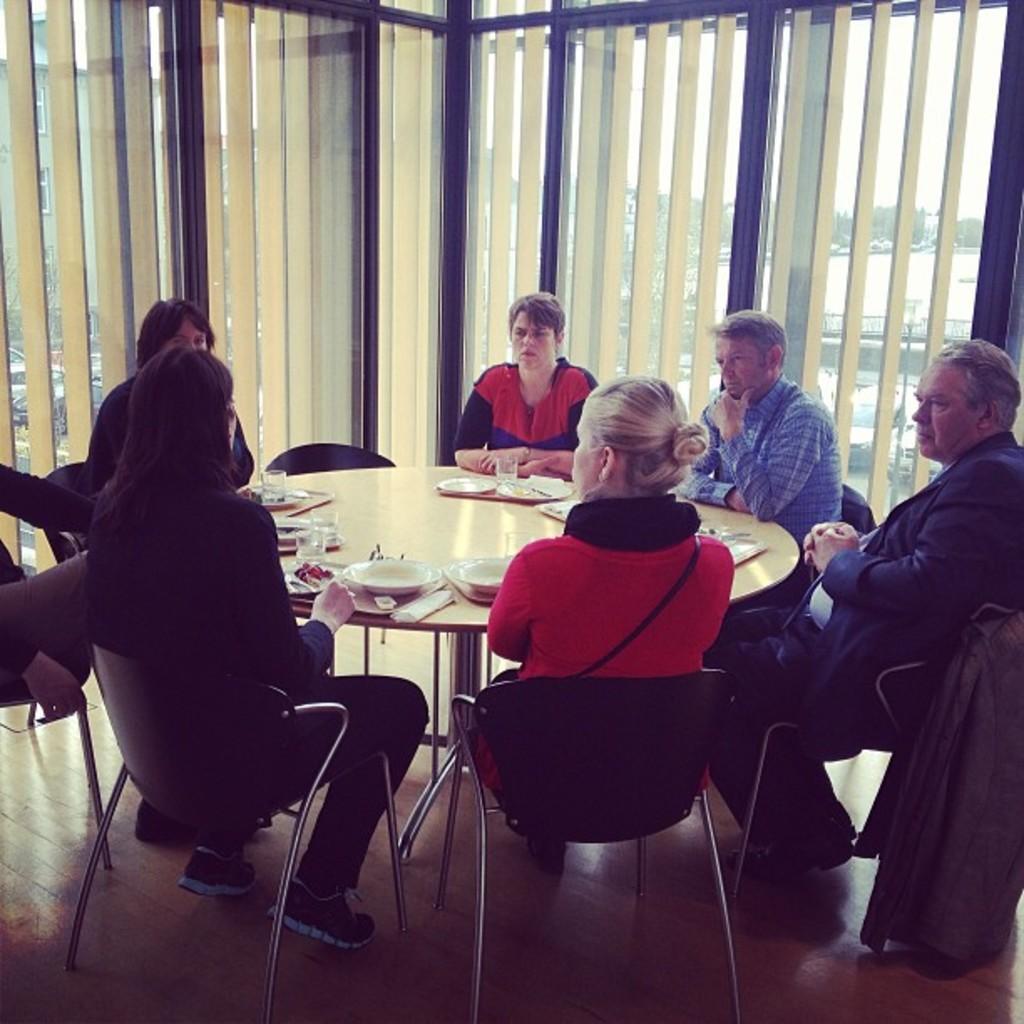In one or two sentences, can you explain what this image depicts? In this picture there are a group of people setting the have a table in front of them and there is a plate, napkins, forks, spoons and in the background is a window 